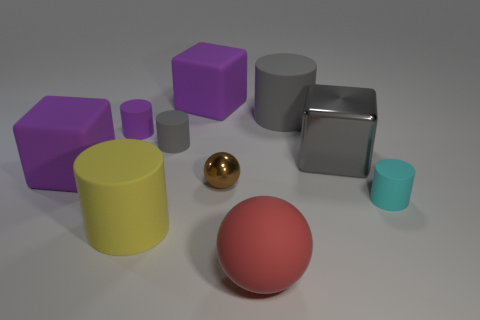What is the color of the small shiny sphere?
Make the answer very short. Brown. What is the shape of the large purple thing on the right side of the gray thing left of the sphere that is in front of the large yellow thing?
Provide a short and direct response. Cube. There is a large object that is in front of the small cyan thing and behind the large matte sphere; what material is it?
Provide a short and direct response. Rubber. What is the shape of the brown shiny thing behind the tiny object to the right of the large metallic cube?
Ensure brevity in your answer.  Sphere. Is there any other thing that has the same color as the big rubber ball?
Keep it short and to the point. No. There is a purple cylinder; is it the same size as the gray matte cylinder on the right side of the brown object?
Ensure brevity in your answer.  No. What number of large objects are brown cubes or purple things?
Give a very brief answer. 2. Is the number of cyan shiny cubes greater than the number of big purple rubber objects?
Your answer should be compact. No. How many small cyan rubber cylinders are on the left side of the purple cube on the left side of the matte block on the right side of the big yellow matte cylinder?
Your answer should be compact. 0. What is the shape of the red rubber thing?
Make the answer very short. Sphere. 